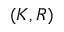Convert formula to latex. <formula><loc_0><loc_0><loc_500><loc_500>( K , R )</formula> 